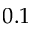<formula> <loc_0><loc_0><loc_500><loc_500>0 . 1</formula> 